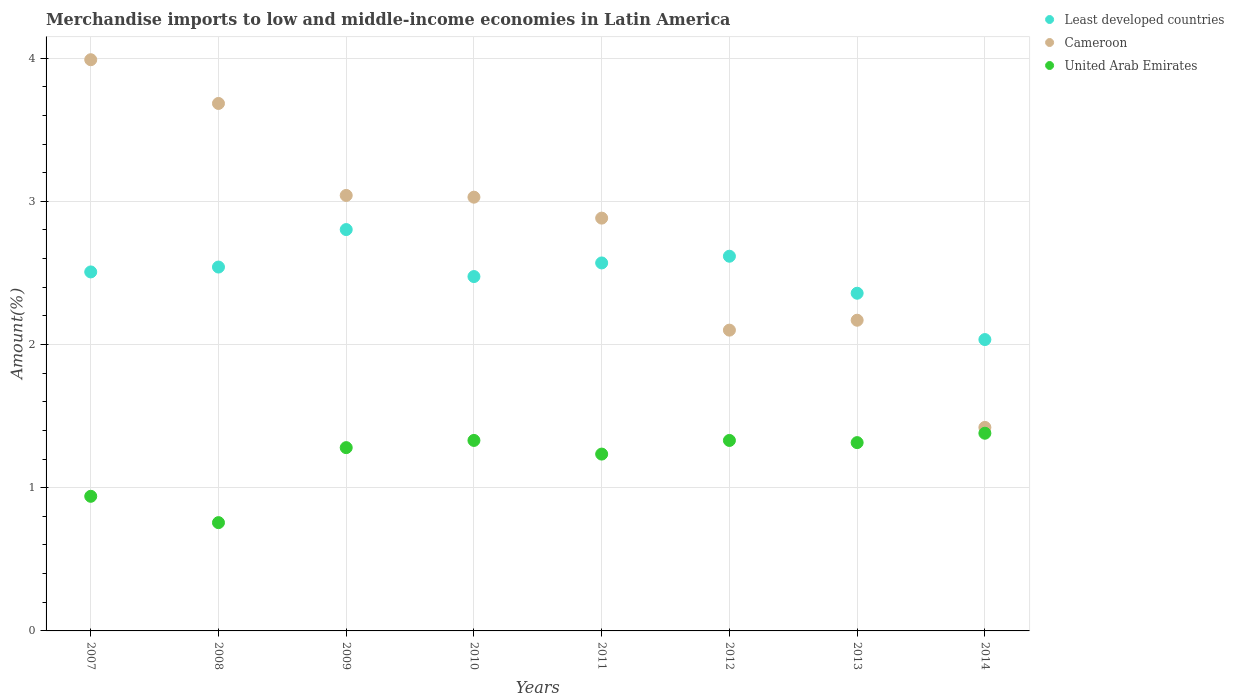What is the percentage of amount earned from merchandise imports in Cameroon in 2012?
Keep it short and to the point. 2.1. Across all years, what is the maximum percentage of amount earned from merchandise imports in United Arab Emirates?
Make the answer very short. 1.38. Across all years, what is the minimum percentage of amount earned from merchandise imports in Cameroon?
Your answer should be very brief. 1.42. What is the total percentage of amount earned from merchandise imports in United Arab Emirates in the graph?
Offer a very short reply. 9.57. What is the difference between the percentage of amount earned from merchandise imports in Least developed countries in 2007 and that in 2011?
Make the answer very short. -0.06. What is the difference between the percentage of amount earned from merchandise imports in United Arab Emirates in 2009 and the percentage of amount earned from merchandise imports in Cameroon in 2012?
Provide a short and direct response. -0.82. What is the average percentage of amount earned from merchandise imports in United Arab Emirates per year?
Give a very brief answer. 1.2. In the year 2009, what is the difference between the percentage of amount earned from merchandise imports in Least developed countries and percentage of amount earned from merchandise imports in Cameroon?
Make the answer very short. -0.24. What is the ratio of the percentage of amount earned from merchandise imports in Cameroon in 2012 to that in 2013?
Give a very brief answer. 0.97. Is the percentage of amount earned from merchandise imports in Cameroon in 2009 less than that in 2010?
Your response must be concise. No. Is the difference between the percentage of amount earned from merchandise imports in Least developed countries in 2008 and 2009 greater than the difference between the percentage of amount earned from merchandise imports in Cameroon in 2008 and 2009?
Provide a short and direct response. No. What is the difference between the highest and the second highest percentage of amount earned from merchandise imports in Cameroon?
Provide a succinct answer. 0.31. What is the difference between the highest and the lowest percentage of amount earned from merchandise imports in Cameroon?
Keep it short and to the point. 2.57. Is the percentage of amount earned from merchandise imports in Cameroon strictly greater than the percentage of amount earned from merchandise imports in United Arab Emirates over the years?
Ensure brevity in your answer.  Yes. Is the percentage of amount earned from merchandise imports in United Arab Emirates strictly less than the percentage of amount earned from merchandise imports in Cameroon over the years?
Your answer should be compact. Yes. How many dotlines are there?
Provide a short and direct response. 3. Does the graph contain grids?
Make the answer very short. Yes. Where does the legend appear in the graph?
Give a very brief answer. Top right. How many legend labels are there?
Provide a short and direct response. 3. What is the title of the graph?
Your answer should be compact. Merchandise imports to low and middle-income economies in Latin America. Does "Sweden" appear as one of the legend labels in the graph?
Your answer should be very brief. No. What is the label or title of the Y-axis?
Offer a terse response. Amount(%). What is the Amount(%) in Least developed countries in 2007?
Keep it short and to the point. 2.51. What is the Amount(%) of Cameroon in 2007?
Offer a very short reply. 3.99. What is the Amount(%) of United Arab Emirates in 2007?
Ensure brevity in your answer.  0.94. What is the Amount(%) in Least developed countries in 2008?
Your answer should be compact. 2.54. What is the Amount(%) in Cameroon in 2008?
Your answer should be very brief. 3.68. What is the Amount(%) of United Arab Emirates in 2008?
Give a very brief answer. 0.76. What is the Amount(%) in Least developed countries in 2009?
Keep it short and to the point. 2.8. What is the Amount(%) of Cameroon in 2009?
Provide a short and direct response. 3.04. What is the Amount(%) of United Arab Emirates in 2009?
Make the answer very short. 1.28. What is the Amount(%) in Least developed countries in 2010?
Provide a succinct answer. 2.47. What is the Amount(%) of Cameroon in 2010?
Keep it short and to the point. 3.03. What is the Amount(%) of United Arab Emirates in 2010?
Give a very brief answer. 1.33. What is the Amount(%) in Least developed countries in 2011?
Ensure brevity in your answer.  2.57. What is the Amount(%) of Cameroon in 2011?
Offer a terse response. 2.88. What is the Amount(%) of United Arab Emirates in 2011?
Your answer should be very brief. 1.23. What is the Amount(%) in Least developed countries in 2012?
Offer a terse response. 2.62. What is the Amount(%) of Cameroon in 2012?
Provide a succinct answer. 2.1. What is the Amount(%) of United Arab Emirates in 2012?
Make the answer very short. 1.33. What is the Amount(%) of Least developed countries in 2013?
Your response must be concise. 2.36. What is the Amount(%) in Cameroon in 2013?
Provide a succinct answer. 2.17. What is the Amount(%) of United Arab Emirates in 2013?
Make the answer very short. 1.31. What is the Amount(%) of Least developed countries in 2014?
Keep it short and to the point. 2.03. What is the Amount(%) of Cameroon in 2014?
Your response must be concise. 1.42. What is the Amount(%) in United Arab Emirates in 2014?
Ensure brevity in your answer.  1.38. Across all years, what is the maximum Amount(%) in Least developed countries?
Ensure brevity in your answer.  2.8. Across all years, what is the maximum Amount(%) of Cameroon?
Your response must be concise. 3.99. Across all years, what is the maximum Amount(%) of United Arab Emirates?
Ensure brevity in your answer.  1.38. Across all years, what is the minimum Amount(%) of Least developed countries?
Provide a short and direct response. 2.03. Across all years, what is the minimum Amount(%) in Cameroon?
Your answer should be compact. 1.42. Across all years, what is the minimum Amount(%) in United Arab Emirates?
Provide a short and direct response. 0.76. What is the total Amount(%) in Least developed countries in the graph?
Your answer should be compact. 19.9. What is the total Amount(%) of Cameroon in the graph?
Your answer should be very brief. 22.32. What is the total Amount(%) of United Arab Emirates in the graph?
Keep it short and to the point. 9.57. What is the difference between the Amount(%) of Least developed countries in 2007 and that in 2008?
Your answer should be compact. -0.03. What is the difference between the Amount(%) of Cameroon in 2007 and that in 2008?
Your response must be concise. 0.31. What is the difference between the Amount(%) of United Arab Emirates in 2007 and that in 2008?
Your answer should be very brief. 0.18. What is the difference between the Amount(%) of Least developed countries in 2007 and that in 2009?
Offer a very short reply. -0.3. What is the difference between the Amount(%) in Cameroon in 2007 and that in 2009?
Your answer should be very brief. 0.95. What is the difference between the Amount(%) of United Arab Emirates in 2007 and that in 2009?
Offer a terse response. -0.34. What is the difference between the Amount(%) in Least developed countries in 2007 and that in 2010?
Offer a terse response. 0.03. What is the difference between the Amount(%) in Cameroon in 2007 and that in 2010?
Keep it short and to the point. 0.96. What is the difference between the Amount(%) of United Arab Emirates in 2007 and that in 2010?
Give a very brief answer. -0.39. What is the difference between the Amount(%) of Least developed countries in 2007 and that in 2011?
Provide a succinct answer. -0.06. What is the difference between the Amount(%) of Cameroon in 2007 and that in 2011?
Ensure brevity in your answer.  1.11. What is the difference between the Amount(%) in United Arab Emirates in 2007 and that in 2011?
Make the answer very short. -0.29. What is the difference between the Amount(%) in Least developed countries in 2007 and that in 2012?
Provide a succinct answer. -0.11. What is the difference between the Amount(%) in Cameroon in 2007 and that in 2012?
Make the answer very short. 1.89. What is the difference between the Amount(%) in United Arab Emirates in 2007 and that in 2012?
Provide a succinct answer. -0.39. What is the difference between the Amount(%) of Least developed countries in 2007 and that in 2013?
Your answer should be compact. 0.15. What is the difference between the Amount(%) of Cameroon in 2007 and that in 2013?
Provide a succinct answer. 1.82. What is the difference between the Amount(%) of United Arab Emirates in 2007 and that in 2013?
Give a very brief answer. -0.37. What is the difference between the Amount(%) in Least developed countries in 2007 and that in 2014?
Your response must be concise. 0.47. What is the difference between the Amount(%) of Cameroon in 2007 and that in 2014?
Make the answer very short. 2.57. What is the difference between the Amount(%) in United Arab Emirates in 2007 and that in 2014?
Make the answer very short. -0.44. What is the difference between the Amount(%) in Least developed countries in 2008 and that in 2009?
Make the answer very short. -0.26. What is the difference between the Amount(%) of Cameroon in 2008 and that in 2009?
Make the answer very short. 0.64. What is the difference between the Amount(%) of United Arab Emirates in 2008 and that in 2009?
Give a very brief answer. -0.52. What is the difference between the Amount(%) in Least developed countries in 2008 and that in 2010?
Keep it short and to the point. 0.07. What is the difference between the Amount(%) in Cameroon in 2008 and that in 2010?
Your response must be concise. 0.65. What is the difference between the Amount(%) of United Arab Emirates in 2008 and that in 2010?
Keep it short and to the point. -0.57. What is the difference between the Amount(%) of Least developed countries in 2008 and that in 2011?
Give a very brief answer. -0.03. What is the difference between the Amount(%) of Cameroon in 2008 and that in 2011?
Provide a succinct answer. 0.8. What is the difference between the Amount(%) of United Arab Emirates in 2008 and that in 2011?
Your answer should be very brief. -0.48. What is the difference between the Amount(%) in Least developed countries in 2008 and that in 2012?
Keep it short and to the point. -0.08. What is the difference between the Amount(%) in Cameroon in 2008 and that in 2012?
Offer a very short reply. 1.58. What is the difference between the Amount(%) of United Arab Emirates in 2008 and that in 2012?
Your answer should be very brief. -0.57. What is the difference between the Amount(%) of Least developed countries in 2008 and that in 2013?
Give a very brief answer. 0.18. What is the difference between the Amount(%) of Cameroon in 2008 and that in 2013?
Your response must be concise. 1.51. What is the difference between the Amount(%) of United Arab Emirates in 2008 and that in 2013?
Offer a terse response. -0.56. What is the difference between the Amount(%) of Least developed countries in 2008 and that in 2014?
Keep it short and to the point. 0.51. What is the difference between the Amount(%) of Cameroon in 2008 and that in 2014?
Ensure brevity in your answer.  2.26. What is the difference between the Amount(%) in United Arab Emirates in 2008 and that in 2014?
Provide a short and direct response. -0.62. What is the difference between the Amount(%) of Least developed countries in 2009 and that in 2010?
Your answer should be compact. 0.33. What is the difference between the Amount(%) of Cameroon in 2009 and that in 2010?
Make the answer very short. 0.01. What is the difference between the Amount(%) of United Arab Emirates in 2009 and that in 2010?
Give a very brief answer. -0.05. What is the difference between the Amount(%) of Least developed countries in 2009 and that in 2011?
Give a very brief answer. 0.23. What is the difference between the Amount(%) of Cameroon in 2009 and that in 2011?
Your answer should be very brief. 0.16. What is the difference between the Amount(%) in United Arab Emirates in 2009 and that in 2011?
Your answer should be very brief. 0.05. What is the difference between the Amount(%) of Least developed countries in 2009 and that in 2012?
Offer a very short reply. 0.19. What is the difference between the Amount(%) of Cameroon in 2009 and that in 2012?
Provide a short and direct response. 0.94. What is the difference between the Amount(%) in United Arab Emirates in 2009 and that in 2012?
Ensure brevity in your answer.  -0.05. What is the difference between the Amount(%) in Least developed countries in 2009 and that in 2013?
Offer a terse response. 0.44. What is the difference between the Amount(%) of Cameroon in 2009 and that in 2013?
Ensure brevity in your answer.  0.87. What is the difference between the Amount(%) in United Arab Emirates in 2009 and that in 2013?
Keep it short and to the point. -0.04. What is the difference between the Amount(%) of Least developed countries in 2009 and that in 2014?
Your answer should be very brief. 0.77. What is the difference between the Amount(%) of Cameroon in 2009 and that in 2014?
Give a very brief answer. 1.62. What is the difference between the Amount(%) of United Arab Emirates in 2009 and that in 2014?
Provide a short and direct response. -0.1. What is the difference between the Amount(%) in Least developed countries in 2010 and that in 2011?
Your response must be concise. -0.1. What is the difference between the Amount(%) of Cameroon in 2010 and that in 2011?
Your answer should be very brief. 0.15. What is the difference between the Amount(%) in United Arab Emirates in 2010 and that in 2011?
Your answer should be compact. 0.1. What is the difference between the Amount(%) in Least developed countries in 2010 and that in 2012?
Provide a succinct answer. -0.14. What is the difference between the Amount(%) of Cameroon in 2010 and that in 2012?
Offer a very short reply. 0.93. What is the difference between the Amount(%) of United Arab Emirates in 2010 and that in 2012?
Provide a succinct answer. 0. What is the difference between the Amount(%) of Least developed countries in 2010 and that in 2013?
Provide a short and direct response. 0.12. What is the difference between the Amount(%) of Cameroon in 2010 and that in 2013?
Ensure brevity in your answer.  0.86. What is the difference between the Amount(%) in United Arab Emirates in 2010 and that in 2013?
Provide a short and direct response. 0.02. What is the difference between the Amount(%) in Least developed countries in 2010 and that in 2014?
Ensure brevity in your answer.  0.44. What is the difference between the Amount(%) in Cameroon in 2010 and that in 2014?
Ensure brevity in your answer.  1.61. What is the difference between the Amount(%) of United Arab Emirates in 2010 and that in 2014?
Offer a very short reply. -0.05. What is the difference between the Amount(%) of Least developed countries in 2011 and that in 2012?
Make the answer very short. -0.05. What is the difference between the Amount(%) of Cameroon in 2011 and that in 2012?
Offer a terse response. 0.78. What is the difference between the Amount(%) of United Arab Emirates in 2011 and that in 2012?
Keep it short and to the point. -0.1. What is the difference between the Amount(%) in Least developed countries in 2011 and that in 2013?
Your answer should be compact. 0.21. What is the difference between the Amount(%) in Cameroon in 2011 and that in 2013?
Your response must be concise. 0.71. What is the difference between the Amount(%) in United Arab Emirates in 2011 and that in 2013?
Give a very brief answer. -0.08. What is the difference between the Amount(%) of Least developed countries in 2011 and that in 2014?
Your response must be concise. 0.54. What is the difference between the Amount(%) in Cameroon in 2011 and that in 2014?
Your response must be concise. 1.46. What is the difference between the Amount(%) in United Arab Emirates in 2011 and that in 2014?
Your answer should be compact. -0.15. What is the difference between the Amount(%) of Least developed countries in 2012 and that in 2013?
Your answer should be very brief. 0.26. What is the difference between the Amount(%) in Cameroon in 2012 and that in 2013?
Offer a very short reply. -0.07. What is the difference between the Amount(%) of United Arab Emirates in 2012 and that in 2013?
Your answer should be compact. 0.02. What is the difference between the Amount(%) of Least developed countries in 2012 and that in 2014?
Your response must be concise. 0.58. What is the difference between the Amount(%) in Cameroon in 2012 and that in 2014?
Provide a short and direct response. 0.68. What is the difference between the Amount(%) in United Arab Emirates in 2012 and that in 2014?
Provide a succinct answer. -0.05. What is the difference between the Amount(%) in Least developed countries in 2013 and that in 2014?
Provide a short and direct response. 0.32. What is the difference between the Amount(%) in Cameroon in 2013 and that in 2014?
Give a very brief answer. 0.75. What is the difference between the Amount(%) of United Arab Emirates in 2013 and that in 2014?
Offer a very short reply. -0.07. What is the difference between the Amount(%) in Least developed countries in 2007 and the Amount(%) in Cameroon in 2008?
Provide a succinct answer. -1.18. What is the difference between the Amount(%) of Least developed countries in 2007 and the Amount(%) of United Arab Emirates in 2008?
Offer a terse response. 1.75. What is the difference between the Amount(%) in Cameroon in 2007 and the Amount(%) in United Arab Emirates in 2008?
Ensure brevity in your answer.  3.23. What is the difference between the Amount(%) in Least developed countries in 2007 and the Amount(%) in Cameroon in 2009?
Your answer should be compact. -0.53. What is the difference between the Amount(%) in Least developed countries in 2007 and the Amount(%) in United Arab Emirates in 2009?
Provide a short and direct response. 1.23. What is the difference between the Amount(%) in Cameroon in 2007 and the Amount(%) in United Arab Emirates in 2009?
Give a very brief answer. 2.71. What is the difference between the Amount(%) of Least developed countries in 2007 and the Amount(%) of Cameroon in 2010?
Keep it short and to the point. -0.52. What is the difference between the Amount(%) of Least developed countries in 2007 and the Amount(%) of United Arab Emirates in 2010?
Make the answer very short. 1.18. What is the difference between the Amount(%) in Cameroon in 2007 and the Amount(%) in United Arab Emirates in 2010?
Your response must be concise. 2.66. What is the difference between the Amount(%) in Least developed countries in 2007 and the Amount(%) in Cameroon in 2011?
Keep it short and to the point. -0.38. What is the difference between the Amount(%) of Least developed countries in 2007 and the Amount(%) of United Arab Emirates in 2011?
Your answer should be very brief. 1.27. What is the difference between the Amount(%) in Cameroon in 2007 and the Amount(%) in United Arab Emirates in 2011?
Make the answer very short. 2.75. What is the difference between the Amount(%) in Least developed countries in 2007 and the Amount(%) in Cameroon in 2012?
Your response must be concise. 0.41. What is the difference between the Amount(%) of Least developed countries in 2007 and the Amount(%) of United Arab Emirates in 2012?
Provide a short and direct response. 1.18. What is the difference between the Amount(%) of Cameroon in 2007 and the Amount(%) of United Arab Emirates in 2012?
Provide a short and direct response. 2.66. What is the difference between the Amount(%) of Least developed countries in 2007 and the Amount(%) of Cameroon in 2013?
Make the answer very short. 0.34. What is the difference between the Amount(%) of Least developed countries in 2007 and the Amount(%) of United Arab Emirates in 2013?
Your answer should be very brief. 1.19. What is the difference between the Amount(%) in Cameroon in 2007 and the Amount(%) in United Arab Emirates in 2013?
Your answer should be very brief. 2.67. What is the difference between the Amount(%) of Least developed countries in 2007 and the Amount(%) of Cameroon in 2014?
Your answer should be compact. 1.09. What is the difference between the Amount(%) in Least developed countries in 2007 and the Amount(%) in United Arab Emirates in 2014?
Provide a succinct answer. 1.13. What is the difference between the Amount(%) in Cameroon in 2007 and the Amount(%) in United Arab Emirates in 2014?
Your answer should be very brief. 2.61. What is the difference between the Amount(%) of Least developed countries in 2008 and the Amount(%) of Cameroon in 2009?
Give a very brief answer. -0.5. What is the difference between the Amount(%) of Least developed countries in 2008 and the Amount(%) of United Arab Emirates in 2009?
Provide a succinct answer. 1.26. What is the difference between the Amount(%) of Cameroon in 2008 and the Amount(%) of United Arab Emirates in 2009?
Make the answer very short. 2.4. What is the difference between the Amount(%) in Least developed countries in 2008 and the Amount(%) in Cameroon in 2010?
Provide a succinct answer. -0.49. What is the difference between the Amount(%) in Least developed countries in 2008 and the Amount(%) in United Arab Emirates in 2010?
Provide a short and direct response. 1.21. What is the difference between the Amount(%) of Cameroon in 2008 and the Amount(%) of United Arab Emirates in 2010?
Provide a succinct answer. 2.35. What is the difference between the Amount(%) of Least developed countries in 2008 and the Amount(%) of Cameroon in 2011?
Offer a very short reply. -0.34. What is the difference between the Amount(%) of Least developed countries in 2008 and the Amount(%) of United Arab Emirates in 2011?
Offer a very short reply. 1.31. What is the difference between the Amount(%) in Cameroon in 2008 and the Amount(%) in United Arab Emirates in 2011?
Give a very brief answer. 2.45. What is the difference between the Amount(%) of Least developed countries in 2008 and the Amount(%) of Cameroon in 2012?
Your answer should be compact. 0.44. What is the difference between the Amount(%) in Least developed countries in 2008 and the Amount(%) in United Arab Emirates in 2012?
Provide a short and direct response. 1.21. What is the difference between the Amount(%) in Cameroon in 2008 and the Amount(%) in United Arab Emirates in 2012?
Ensure brevity in your answer.  2.35. What is the difference between the Amount(%) in Least developed countries in 2008 and the Amount(%) in Cameroon in 2013?
Keep it short and to the point. 0.37. What is the difference between the Amount(%) of Least developed countries in 2008 and the Amount(%) of United Arab Emirates in 2013?
Give a very brief answer. 1.23. What is the difference between the Amount(%) of Cameroon in 2008 and the Amount(%) of United Arab Emirates in 2013?
Keep it short and to the point. 2.37. What is the difference between the Amount(%) of Least developed countries in 2008 and the Amount(%) of Cameroon in 2014?
Provide a succinct answer. 1.12. What is the difference between the Amount(%) in Least developed countries in 2008 and the Amount(%) in United Arab Emirates in 2014?
Your answer should be compact. 1.16. What is the difference between the Amount(%) in Cameroon in 2008 and the Amount(%) in United Arab Emirates in 2014?
Keep it short and to the point. 2.3. What is the difference between the Amount(%) in Least developed countries in 2009 and the Amount(%) in Cameroon in 2010?
Your answer should be very brief. -0.23. What is the difference between the Amount(%) of Least developed countries in 2009 and the Amount(%) of United Arab Emirates in 2010?
Make the answer very short. 1.47. What is the difference between the Amount(%) in Cameroon in 2009 and the Amount(%) in United Arab Emirates in 2010?
Offer a very short reply. 1.71. What is the difference between the Amount(%) of Least developed countries in 2009 and the Amount(%) of Cameroon in 2011?
Give a very brief answer. -0.08. What is the difference between the Amount(%) in Least developed countries in 2009 and the Amount(%) in United Arab Emirates in 2011?
Provide a short and direct response. 1.57. What is the difference between the Amount(%) of Cameroon in 2009 and the Amount(%) of United Arab Emirates in 2011?
Ensure brevity in your answer.  1.81. What is the difference between the Amount(%) of Least developed countries in 2009 and the Amount(%) of Cameroon in 2012?
Provide a succinct answer. 0.7. What is the difference between the Amount(%) of Least developed countries in 2009 and the Amount(%) of United Arab Emirates in 2012?
Make the answer very short. 1.47. What is the difference between the Amount(%) in Cameroon in 2009 and the Amount(%) in United Arab Emirates in 2012?
Offer a very short reply. 1.71. What is the difference between the Amount(%) in Least developed countries in 2009 and the Amount(%) in Cameroon in 2013?
Provide a short and direct response. 0.63. What is the difference between the Amount(%) in Least developed countries in 2009 and the Amount(%) in United Arab Emirates in 2013?
Ensure brevity in your answer.  1.49. What is the difference between the Amount(%) in Cameroon in 2009 and the Amount(%) in United Arab Emirates in 2013?
Your answer should be compact. 1.73. What is the difference between the Amount(%) in Least developed countries in 2009 and the Amount(%) in Cameroon in 2014?
Your answer should be very brief. 1.38. What is the difference between the Amount(%) in Least developed countries in 2009 and the Amount(%) in United Arab Emirates in 2014?
Offer a terse response. 1.42. What is the difference between the Amount(%) of Cameroon in 2009 and the Amount(%) of United Arab Emirates in 2014?
Keep it short and to the point. 1.66. What is the difference between the Amount(%) in Least developed countries in 2010 and the Amount(%) in Cameroon in 2011?
Your answer should be compact. -0.41. What is the difference between the Amount(%) of Least developed countries in 2010 and the Amount(%) of United Arab Emirates in 2011?
Offer a terse response. 1.24. What is the difference between the Amount(%) in Cameroon in 2010 and the Amount(%) in United Arab Emirates in 2011?
Ensure brevity in your answer.  1.79. What is the difference between the Amount(%) in Least developed countries in 2010 and the Amount(%) in Cameroon in 2012?
Give a very brief answer. 0.37. What is the difference between the Amount(%) of Least developed countries in 2010 and the Amount(%) of United Arab Emirates in 2012?
Your answer should be compact. 1.14. What is the difference between the Amount(%) of Cameroon in 2010 and the Amount(%) of United Arab Emirates in 2012?
Offer a very short reply. 1.7. What is the difference between the Amount(%) in Least developed countries in 2010 and the Amount(%) in Cameroon in 2013?
Make the answer very short. 0.3. What is the difference between the Amount(%) in Least developed countries in 2010 and the Amount(%) in United Arab Emirates in 2013?
Offer a terse response. 1.16. What is the difference between the Amount(%) in Cameroon in 2010 and the Amount(%) in United Arab Emirates in 2013?
Offer a very short reply. 1.71. What is the difference between the Amount(%) in Least developed countries in 2010 and the Amount(%) in Cameroon in 2014?
Your answer should be very brief. 1.05. What is the difference between the Amount(%) of Least developed countries in 2010 and the Amount(%) of United Arab Emirates in 2014?
Give a very brief answer. 1.09. What is the difference between the Amount(%) of Cameroon in 2010 and the Amount(%) of United Arab Emirates in 2014?
Provide a short and direct response. 1.65. What is the difference between the Amount(%) of Least developed countries in 2011 and the Amount(%) of Cameroon in 2012?
Ensure brevity in your answer.  0.47. What is the difference between the Amount(%) in Least developed countries in 2011 and the Amount(%) in United Arab Emirates in 2012?
Give a very brief answer. 1.24. What is the difference between the Amount(%) in Cameroon in 2011 and the Amount(%) in United Arab Emirates in 2012?
Keep it short and to the point. 1.55. What is the difference between the Amount(%) in Least developed countries in 2011 and the Amount(%) in Cameroon in 2013?
Keep it short and to the point. 0.4. What is the difference between the Amount(%) in Least developed countries in 2011 and the Amount(%) in United Arab Emirates in 2013?
Provide a short and direct response. 1.25. What is the difference between the Amount(%) of Cameroon in 2011 and the Amount(%) of United Arab Emirates in 2013?
Give a very brief answer. 1.57. What is the difference between the Amount(%) of Least developed countries in 2011 and the Amount(%) of Cameroon in 2014?
Your answer should be compact. 1.15. What is the difference between the Amount(%) of Least developed countries in 2011 and the Amount(%) of United Arab Emirates in 2014?
Offer a very short reply. 1.19. What is the difference between the Amount(%) in Cameroon in 2011 and the Amount(%) in United Arab Emirates in 2014?
Your response must be concise. 1.5. What is the difference between the Amount(%) of Least developed countries in 2012 and the Amount(%) of Cameroon in 2013?
Offer a very short reply. 0.45. What is the difference between the Amount(%) of Least developed countries in 2012 and the Amount(%) of United Arab Emirates in 2013?
Provide a short and direct response. 1.3. What is the difference between the Amount(%) in Cameroon in 2012 and the Amount(%) in United Arab Emirates in 2013?
Keep it short and to the point. 0.79. What is the difference between the Amount(%) in Least developed countries in 2012 and the Amount(%) in Cameroon in 2014?
Ensure brevity in your answer.  1.2. What is the difference between the Amount(%) in Least developed countries in 2012 and the Amount(%) in United Arab Emirates in 2014?
Keep it short and to the point. 1.24. What is the difference between the Amount(%) of Cameroon in 2012 and the Amount(%) of United Arab Emirates in 2014?
Ensure brevity in your answer.  0.72. What is the difference between the Amount(%) in Least developed countries in 2013 and the Amount(%) in Cameroon in 2014?
Provide a short and direct response. 0.94. What is the difference between the Amount(%) in Least developed countries in 2013 and the Amount(%) in United Arab Emirates in 2014?
Offer a terse response. 0.98. What is the difference between the Amount(%) of Cameroon in 2013 and the Amount(%) of United Arab Emirates in 2014?
Your answer should be compact. 0.79. What is the average Amount(%) in Least developed countries per year?
Your answer should be compact. 2.49. What is the average Amount(%) in Cameroon per year?
Your answer should be compact. 2.79. What is the average Amount(%) in United Arab Emirates per year?
Ensure brevity in your answer.  1.2. In the year 2007, what is the difference between the Amount(%) in Least developed countries and Amount(%) in Cameroon?
Your response must be concise. -1.48. In the year 2007, what is the difference between the Amount(%) in Least developed countries and Amount(%) in United Arab Emirates?
Give a very brief answer. 1.57. In the year 2007, what is the difference between the Amount(%) of Cameroon and Amount(%) of United Arab Emirates?
Offer a very short reply. 3.05. In the year 2008, what is the difference between the Amount(%) in Least developed countries and Amount(%) in Cameroon?
Provide a short and direct response. -1.14. In the year 2008, what is the difference between the Amount(%) of Least developed countries and Amount(%) of United Arab Emirates?
Offer a very short reply. 1.78. In the year 2008, what is the difference between the Amount(%) in Cameroon and Amount(%) in United Arab Emirates?
Provide a short and direct response. 2.93. In the year 2009, what is the difference between the Amount(%) of Least developed countries and Amount(%) of Cameroon?
Offer a terse response. -0.24. In the year 2009, what is the difference between the Amount(%) of Least developed countries and Amount(%) of United Arab Emirates?
Make the answer very short. 1.52. In the year 2009, what is the difference between the Amount(%) of Cameroon and Amount(%) of United Arab Emirates?
Offer a terse response. 1.76. In the year 2010, what is the difference between the Amount(%) in Least developed countries and Amount(%) in Cameroon?
Make the answer very short. -0.55. In the year 2010, what is the difference between the Amount(%) in Least developed countries and Amount(%) in United Arab Emirates?
Keep it short and to the point. 1.14. In the year 2010, what is the difference between the Amount(%) of Cameroon and Amount(%) of United Arab Emirates?
Offer a very short reply. 1.7. In the year 2011, what is the difference between the Amount(%) of Least developed countries and Amount(%) of Cameroon?
Make the answer very short. -0.31. In the year 2011, what is the difference between the Amount(%) in Least developed countries and Amount(%) in United Arab Emirates?
Offer a terse response. 1.33. In the year 2011, what is the difference between the Amount(%) of Cameroon and Amount(%) of United Arab Emirates?
Your answer should be compact. 1.65. In the year 2012, what is the difference between the Amount(%) of Least developed countries and Amount(%) of Cameroon?
Your response must be concise. 0.52. In the year 2012, what is the difference between the Amount(%) of Least developed countries and Amount(%) of United Arab Emirates?
Your response must be concise. 1.29. In the year 2012, what is the difference between the Amount(%) in Cameroon and Amount(%) in United Arab Emirates?
Your answer should be very brief. 0.77. In the year 2013, what is the difference between the Amount(%) of Least developed countries and Amount(%) of Cameroon?
Offer a very short reply. 0.19. In the year 2013, what is the difference between the Amount(%) in Least developed countries and Amount(%) in United Arab Emirates?
Your response must be concise. 1.04. In the year 2013, what is the difference between the Amount(%) of Cameroon and Amount(%) of United Arab Emirates?
Keep it short and to the point. 0.85. In the year 2014, what is the difference between the Amount(%) in Least developed countries and Amount(%) in Cameroon?
Your answer should be very brief. 0.61. In the year 2014, what is the difference between the Amount(%) in Least developed countries and Amount(%) in United Arab Emirates?
Offer a terse response. 0.65. In the year 2014, what is the difference between the Amount(%) of Cameroon and Amount(%) of United Arab Emirates?
Provide a succinct answer. 0.04. What is the ratio of the Amount(%) of Least developed countries in 2007 to that in 2008?
Your response must be concise. 0.99. What is the ratio of the Amount(%) in Cameroon in 2007 to that in 2008?
Your answer should be very brief. 1.08. What is the ratio of the Amount(%) of United Arab Emirates in 2007 to that in 2008?
Offer a very short reply. 1.24. What is the ratio of the Amount(%) in Least developed countries in 2007 to that in 2009?
Offer a very short reply. 0.89. What is the ratio of the Amount(%) of Cameroon in 2007 to that in 2009?
Keep it short and to the point. 1.31. What is the ratio of the Amount(%) in United Arab Emirates in 2007 to that in 2009?
Offer a very short reply. 0.73. What is the ratio of the Amount(%) in Cameroon in 2007 to that in 2010?
Your response must be concise. 1.32. What is the ratio of the Amount(%) of United Arab Emirates in 2007 to that in 2010?
Keep it short and to the point. 0.71. What is the ratio of the Amount(%) in Least developed countries in 2007 to that in 2011?
Provide a succinct answer. 0.98. What is the ratio of the Amount(%) of Cameroon in 2007 to that in 2011?
Ensure brevity in your answer.  1.38. What is the ratio of the Amount(%) of United Arab Emirates in 2007 to that in 2011?
Offer a very short reply. 0.76. What is the ratio of the Amount(%) in Least developed countries in 2007 to that in 2012?
Your answer should be compact. 0.96. What is the ratio of the Amount(%) of Cameroon in 2007 to that in 2012?
Your response must be concise. 1.9. What is the ratio of the Amount(%) in United Arab Emirates in 2007 to that in 2012?
Your response must be concise. 0.71. What is the ratio of the Amount(%) of Least developed countries in 2007 to that in 2013?
Give a very brief answer. 1.06. What is the ratio of the Amount(%) in Cameroon in 2007 to that in 2013?
Your answer should be compact. 1.84. What is the ratio of the Amount(%) of United Arab Emirates in 2007 to that in 2013?
Offer a terse response. 0.71. What is the ratio of the Amount(%) in Least developed countries in 2007 to that in 2014?
Ensure brevity in your answer.  1.23. What is the ratio of the Amount(%) of Cameroon in 2007 to that in 2014?
Offer a terse response. 2.81. What is the ratio of the Amount(%) in United Arab Emirates in 2007 to that in 2014?
Offer a terse response. 0.68. What is the ratio of the Amount(%) in Least developed countries in 2008 to that in 2009?
Provide a succinct answer. 0.91. What is the ratio of the Amount(%) in Cameroon in 2008 to that in 2009?
Your response must be concise. 1.21. What is the ratio of the Amount(%) in United Arab Emirates in 2008 to that in 2009?
Give a very brief answer. 0.59. What is the ratio of the Amount(%) of Least developed countries in 2008 to that in 2010?
Give a very brief answer. 1.03. What is the ratio of the Amount(%) of Cameroon in 2008 to that in 2010?
Give a very brief answer. 1.22. What is the ratio of the Amount(%) of United Arab Emirates in 2008 to that in 2010?
Keep it short and to the point. 0.57. What is the ratio of the Amount(%) in Least developed countries in 2008 to that in 2011?
Ensure brevity in your answer.  0.99. What is the ratio of the Amount(%) in Cameroon in 2008 to that in 2011?
Give a very brief answer. 1.28. What is the ratio of the Amount(%) in United Arab Emirates in 2008 to that in 2011?
Make the answer very short. 0.61. What is the ratio of the Amount(%) in Least developed countries in 2008 to that in 2012?
Make the answer very short. 0.97. What is the ratio of the Amount(%) of Cameroon in 2008 to that in 2012?
Your response must be concise. 1.75. What is the ratio of the Amount(%) of United Arab Emirates in 2008 to that in 2012?
Keep it short and to the point. 0.57. What is the ratio of the Amount(%) of Least developed countries in 2008 to that in 2013?
Offer a very short reply. 1.08. What is the ratio of the Amount(%) of Cameroon in 2008 to that in 2013?
Your answer should be compact. 1.7. What is the ratio of the Amount(%) of United Arab Emirates in 2008 to that in 2013?
Make the answer very short. 0.58. What is the ratio of the Amount(%) of Least developed countries in 2008 to that in 2014?
Provide a short and direct response. 1.25. What is the ratio of the Amount(%) in Cameroon in 2008 to that in 2014?
Ensure brevity in your answer.  2.59. What is the ratio of the Amount(%) of United Arab Emirates in 2008 to that in 2014?
Provide a succinct answer. 0.55. What is the ratio of the Amount(%) of Least developed countries in 2009 to that in 2010?
Offer a terse response. 1.13. What is the ratio of the Amount(%) in Cameroon in 2009 to that in 2010?
Offer a terse response. 1. What is the ratio of the Amount(%) of United Arab Emirates in 2009 to that in 2010?
Your answer should be compact. 0.96. What is the ratio of the Amount(%) of Least developed countries in 2009 to that in 2011?
Offer a very short reply. 1.09. What is the ratio of the Amount(%) in Cameroon in 2009 to that in 2011?
Your answer should be very brief. 1.05. What is the ratio of the Amount(%) of United Arab Emirates in 2009 to that in 2011?
Ensure brevity in your answer.  1.04. What is the ratio of the Amount(%) of Least developed countries in 2009 to that in 2012?
Ensure brevity in your answer.  1.07. What is the ratio of the Amount(%) in Cameroon in 2009 to that in 2012?
Offer a very short reply. 1.45. What is the ratio of the Amount(%) in United Arab Emirates in 2009 to that in 2012?
Your response must be concise. 0.96. What is the ratio of the Amount(%) of Least developed countries in 2009 to that in 2013?
Ensure brevity in your answer.  1.19. What is the ratio of the Amount(%) of Cameroon in 2009 to that in 2013?
Keep it short and to the point. 1.4. What is the ratio of the Amount(%) of United Arab Emirates in 2009 to that in 2013?
Your response must be concise. 0.97. What is the ratio of the Amount(%) in Least developed countries in 2009 to that in 2014?
Offer a terse response. 1.38. What is the ratio of the Amount(%) in Cameroon in 2009 to that in 2014?
Offer a very short reply. 2.14. What is the ratio of the Amount(%) in United Arab Emirates in 2009 to that in 2014?
Offer a terse response. 0.93. What is the ratio of the Amount(%) in Least developed countries in 2010 to that in 2011?
Ensure brevity in your answer.  0.96. What is the ratio of the Amount(%) in Cameroon in 2010 to that in 2011?
Provide a short and direct response. 1.05. What is the ratio of the Amount(%) of United Arab Emirates in 2010 to that in 2011?
Provide a succinct answer. 1.08. What is the ratio of the Amount(%) of Least developed countries in 2010 to that in 2012?
Offer a terse response. 0.95. What is the ratio of the Amount(%) in Cameroon in 2010 to that in 2012?
Keep it short and to the point. 1.44. What is the ratio of the Amount(%) of United Arab Emirates in 2010 to that in 2012?
Provide a short and direct response. 1. What is the ratio of the Amount(%) in Least developed countries in 2010 to that in 2013?
Ensure brevity in your answer.  1.05. What is the ratio of the Amount(%) in Cameroon in 2010 to that in 2013?
Your answer should be compact. 1.4. What is the ratio of the Amount(%) in United Arab Emirates in 2010 to that in 2013?
Ensure brevity in your answer.  1.01. What is the ratio of the Amount(%) of Least developed countries in 2010 to that in 2014?
Provide a succinct answer. 1.22. What is the ratio of the Amount(%) in Cameroon in 2010 to that in 2014?
Keep it short and to the point. 2.13. What is the ratio of the Amount(%) of United Arab Emirates in 2010 to that in 2014?
Provide a succinct answer. 0.96. What is the ratio of the Amount(%) in Least developed countries in 2011 to that in 2012?
Provide a succinct answer. 0.98. What is the ratio of the Amount(%) in Cameroon in 2011 to that in 2012?
Provide a short and direct response. 1.37. What is the ratio of the Amount(%) in United Arab Emirates in 2011 to that in 2012?
Ensure brevity in your answer.  0.93. What is the ratio of the Amount(%) in Least developed countries in 2011 to that in 2013?
Make the answer very short. 1.09. What is the ratio of the Amount(%) in Cameroon in 2011 to that in 2013?
Provide a succinct answer. 1.33. What is the ratio of the Amount(%) of United Arab Emirates in 2011 to that in 2013?
Provide a short and direct response. 0.94. What is the ratio of the Amount(%) in Least developed countries in 2011 to that in 2014?
Your response must be concise. 1.26. What is the ratio of the Amount(%) in Cameroon in 2011 to that in 2014?
Ensure brevity in your answer.  2.03. What is the ratio of the Amount(%) of United Arab Emirates in 2011 to that in 2014?
Make the answer very short. 0.89. What is the ratio of the Amount(%) of Least developed countries in 2012 to that in 2013?
Make the answer very short. 1.11. What is the ratio of the Amount(%) in Cameroon in 2012 to that in 2013?
Provide a short and direct response. 0.97. What is the ratio of the Amount(%) in United Arab Emirates in 2012 to that in 2013?
Provide a succinct answer. 1.01. What is the ratio of the Amount(%) of Least developed countries in 2012 to that in 2014?
Offer a terse response. 1.29. What is the ratio of the Amount(%) of Cameroon in 2012 to that in 2014?
Make the answer very short. 1.48. What is the ratio of the Amount(%) in United Arab Emirates in 2012 to that in 2014?
Keep it short and to the point. 0.96. What is the ratio of the Amount(%) in Least developed countries in 2013 to that in 2014?
Your answer should be very brief. 1.16. What is the ratio of the Amount(%) in Cameroon in 2013 to that in 2014?
Give a very brief answer. 1.53. What is the ratio of the Amount(%) in United Arab Emirates in 2013 to that in 2014?
Offer a terse response. 0.95. What is the difference between the highest and the second highest Amount(%) of Least developed countries?
Keep it short and to the point. 0.19. What is the difference between the highest and the second highest Amount(%) in Cameroon?
Keep it short and to the point. 0.31. What is the difference between the highest and the second highest Amount(%) of United Arab Emirates?
Ensure brevity in your answer.  0.05. What is the difference between the highest and the lowest Amount(%) of Least developed countries?
Offer a terse response. 0.77. What is the difference between the highest and the lowest Amount(%) of Cameroon?
Give a very brief answer. 2.57. What is the difference between the highest and the lowest Amount(%) of United Arab Emirates?
Your response must be concise. 0.62. 